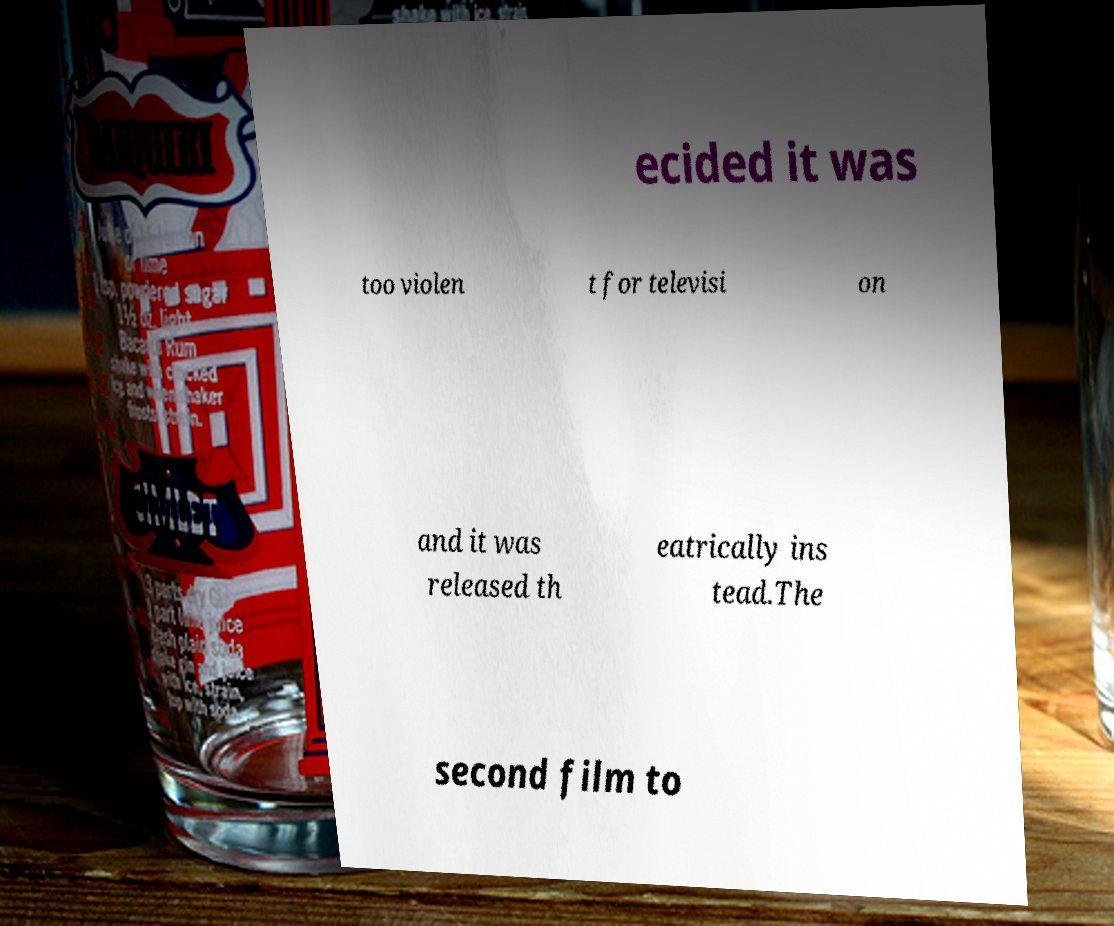What messages or text are displayed in this image? I need them in a readable, typed format. ecided it was too violen t for televisi on and it was released th eatrically ins tead.The second film to 